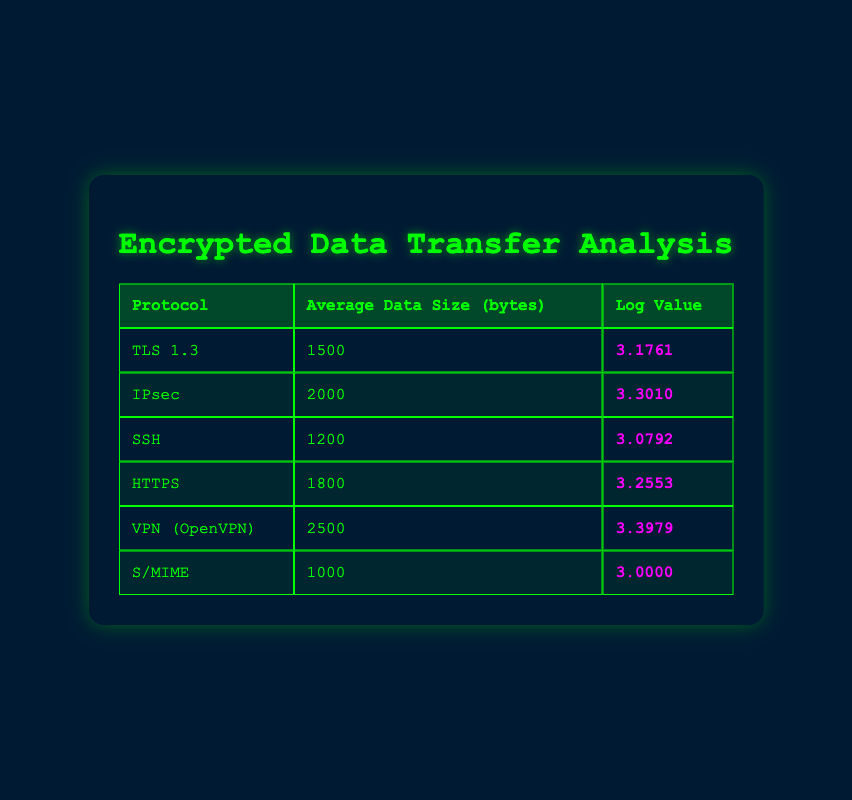What is the average data size for the IPsec protocol? The second row of the table indicates that the average data size for the IPsec protocol is 2000 bytes.
Answer: 2000 bytes Which protocol has the highest average data size in bytes? By comparing the average data sizes listed in the table, VPN (OpenVPN) has the highest value at 2500 bytes.
Answer: VPN (OpenVPN) What is the log value for the HTTPS protocol? The log value corresponding to the HTTPS protocol can be found in the fourth row, which shows it as 3.2553.
Answer: 3.2553 Is the average data size of SSH greater than that of TLS 1.3? The average data size for SSH is 1200 bytes and for TLS 1.3 it is 1500 bytes. Since 1200 is not greater than 1500, the answer is no.
Answer: No What is the average of the average data sizes for TLS 1.3 and HTTPS? To calculate the average: (1500 + 1800) / 2 = 3300 / 2 = 1650 bytes. Therefore, the average average data size for TLS 1.3 and HTTPS is 1650 bytes.
Answer: 1650 bytes Which protocol has a log value that is less than 3.1? By looking at the log values listed, S/MIME has a log value of 3.0000, which is less than 3.1. Therefore, the answer is S/MIME.
Answer: S/MIME How much larger is the average data size of VPN (OpenVPN) compared to SSH? The average data size for VPN (OpenVPN) is 2500 bytes, and for SSH, it is 1200 bytes. The difference is 2500 - 1200 = 1300 bytes.
Answer: 1300 bytes Is there a protocol in the table with an average data size of exactly 1000 bytes? The table indicates that S/MIME has an average data size of 1000 bytes, confirming the existence of such a protocol.
Answer: Yes What is the sum of log values for all protocols listed? Adding the log values together: 3.1761 + 3.3010 + 3.0792 + 3.2553 + 3.3979 + 3.0000 = 19.2095, which represents the total sum of the log values for all protocols listed.
Answer: 19.2095 